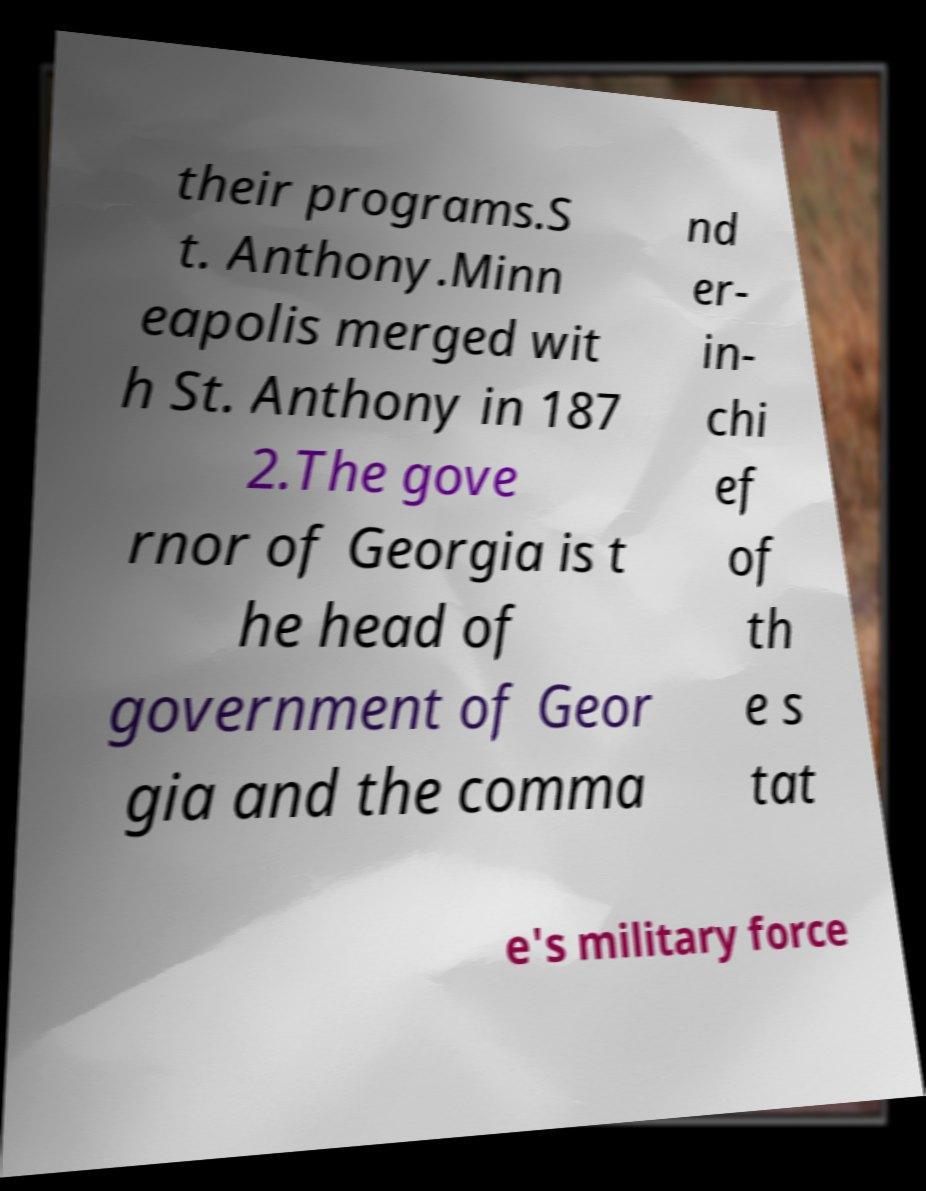Can you read and provide the text displayed in the image?This photo seems to have some interesting text. Can you extract and type it out for me? their programs.S t. Anthony.Minn eapolis merged wit h St. Anthony in 187 2.The gove rnor of Georgia is t he head of government of Geor gia and the comma nd er- in- chi ef of th e s tat e's military force 